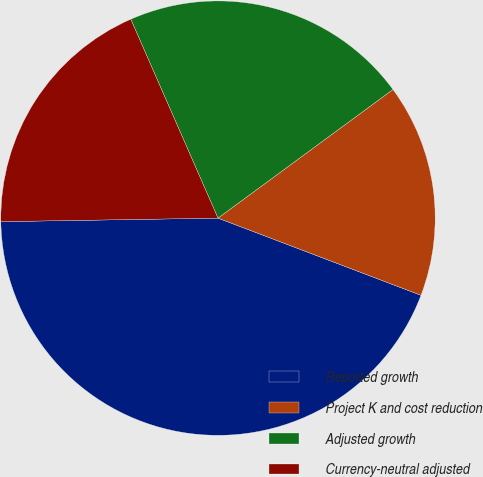Convert chart to OTSL. <chart><loc_0><loc_0><loc_500><loc_500><pie_chart><fcel>Reported growth<fcel>Project K and cost reduction<fcel>Adjusted growth<fcel>Currency-neutral adjusted<nl><fcel>43.96%<fcel>15.87%<fcel>21.49%<fcel>18.68%<nl></chart> 